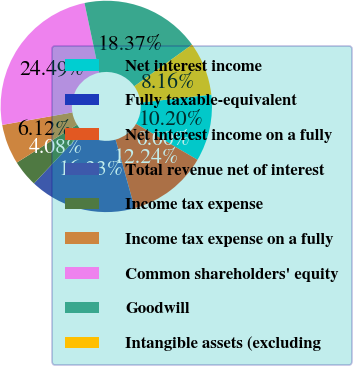Convert chart. <chart><loc_0><loc_0><loc_500><loc_500><pie_chart><fcel>Net interest income<fcel>Fully taxable-equivalent<fcel>Net interest income on a fully<fcel>Total revenue net of interest<fcel>Income tax expense<fcel>Income tax expense on a fully<fcel>Common shareholders' equity<fcel>Goodwill<fcel>Intangible assets (excluding<nl><fcel>10.2%<fcel>0.0%<fcel>12.24%<fcel>16.33%<fcel>4.08%<fcel>6.12%<fcel>24.49%<fcel>18.37%<fcel>8.16%<nl></chart> 